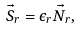Convert formula to latex. <formula><loc_0><loc_0><loc_500><loc_500>\vec { S } _ { r } = \epsilon _ { r } \vec { N } _ { r } ,</formula> 